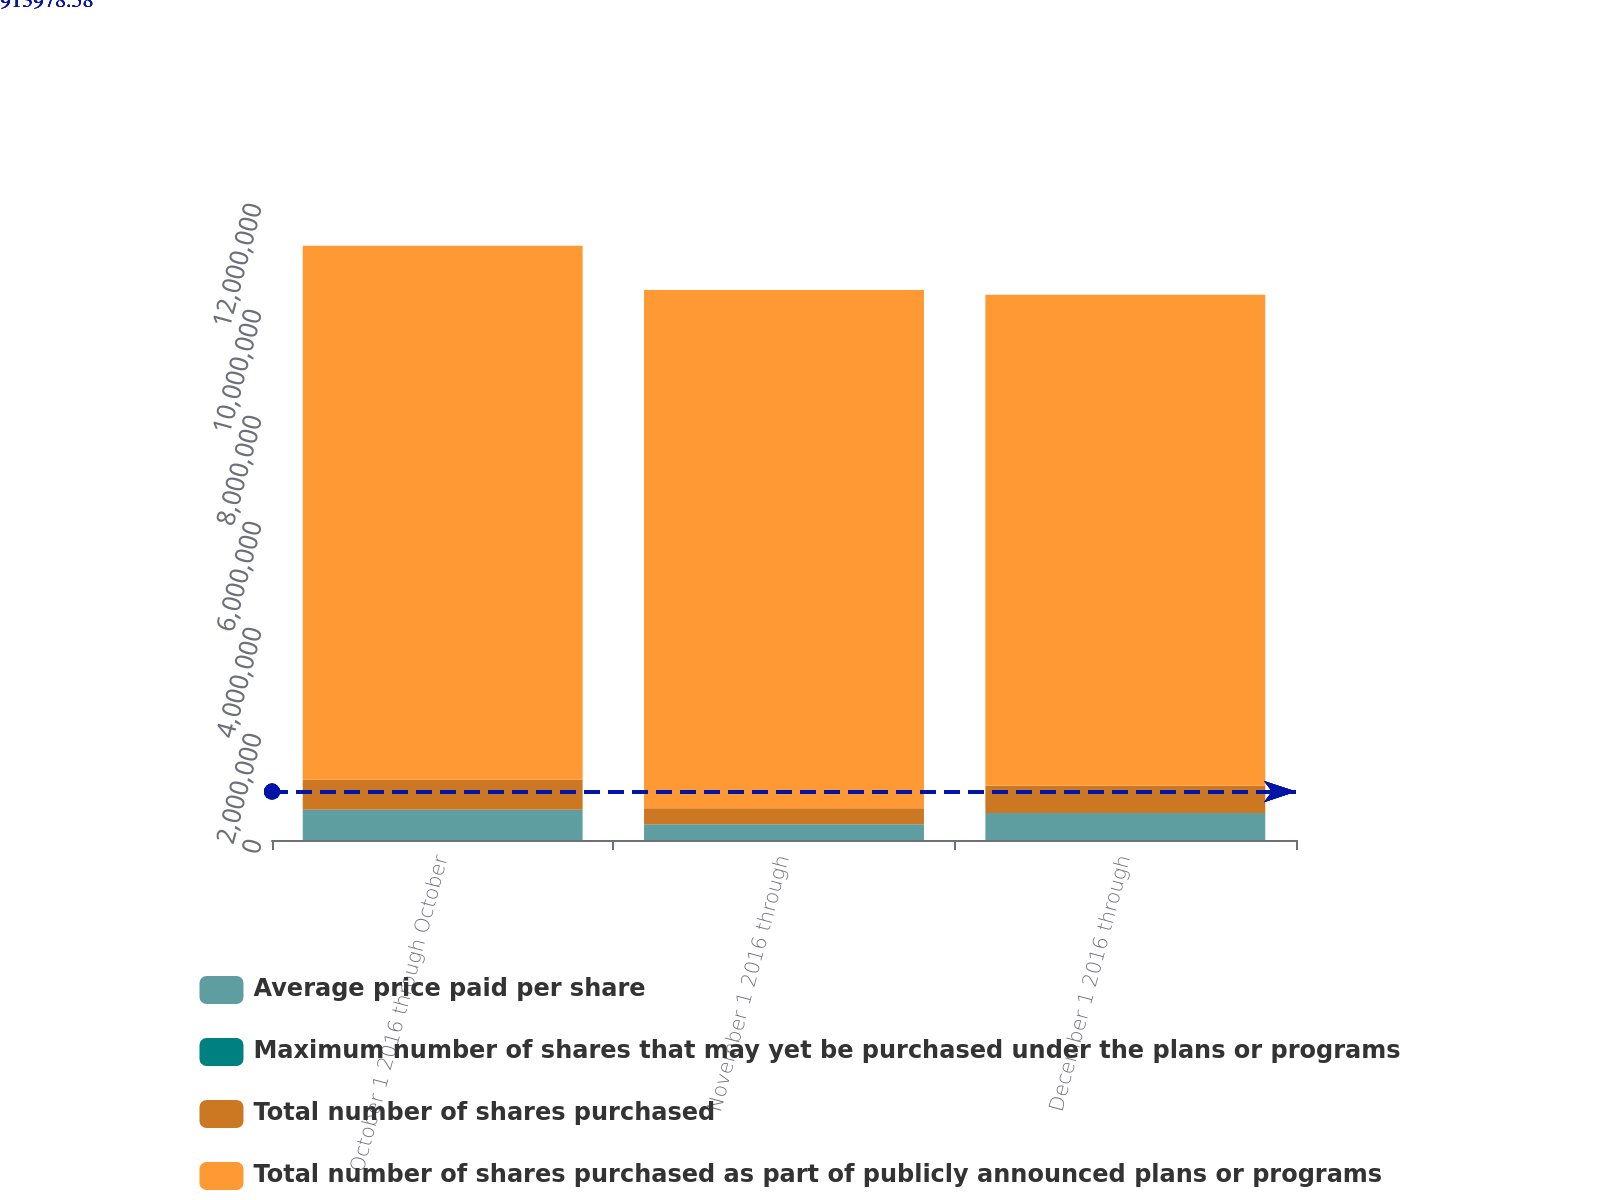<chart> <loc_0><loc_0><loc_500><loc_500><stacked_bar_chart><ecel><fcel>October 1 2016 through October<fcel>November 1 2016 through<fcel>December 1 2016 through<nl><fcel>Average price paid per share<fcel>568906<fcel>298998<fcel>511092<nl><fcel>Maximum number of shares that may yet be purchased under the plans or programs<fcel>129.19<fcel>123.59<fcel>123.16<nl><fcel>Total number of shares purchased<fcel>568906<fcel>298998<fcel>511092<nl><fcel>Total number of shares purchased as part of publicly announced plans or programs<fcel>1.00765e+07<fcel>9.7775e+06<fcel>9.26641e+06<nl></chart> 